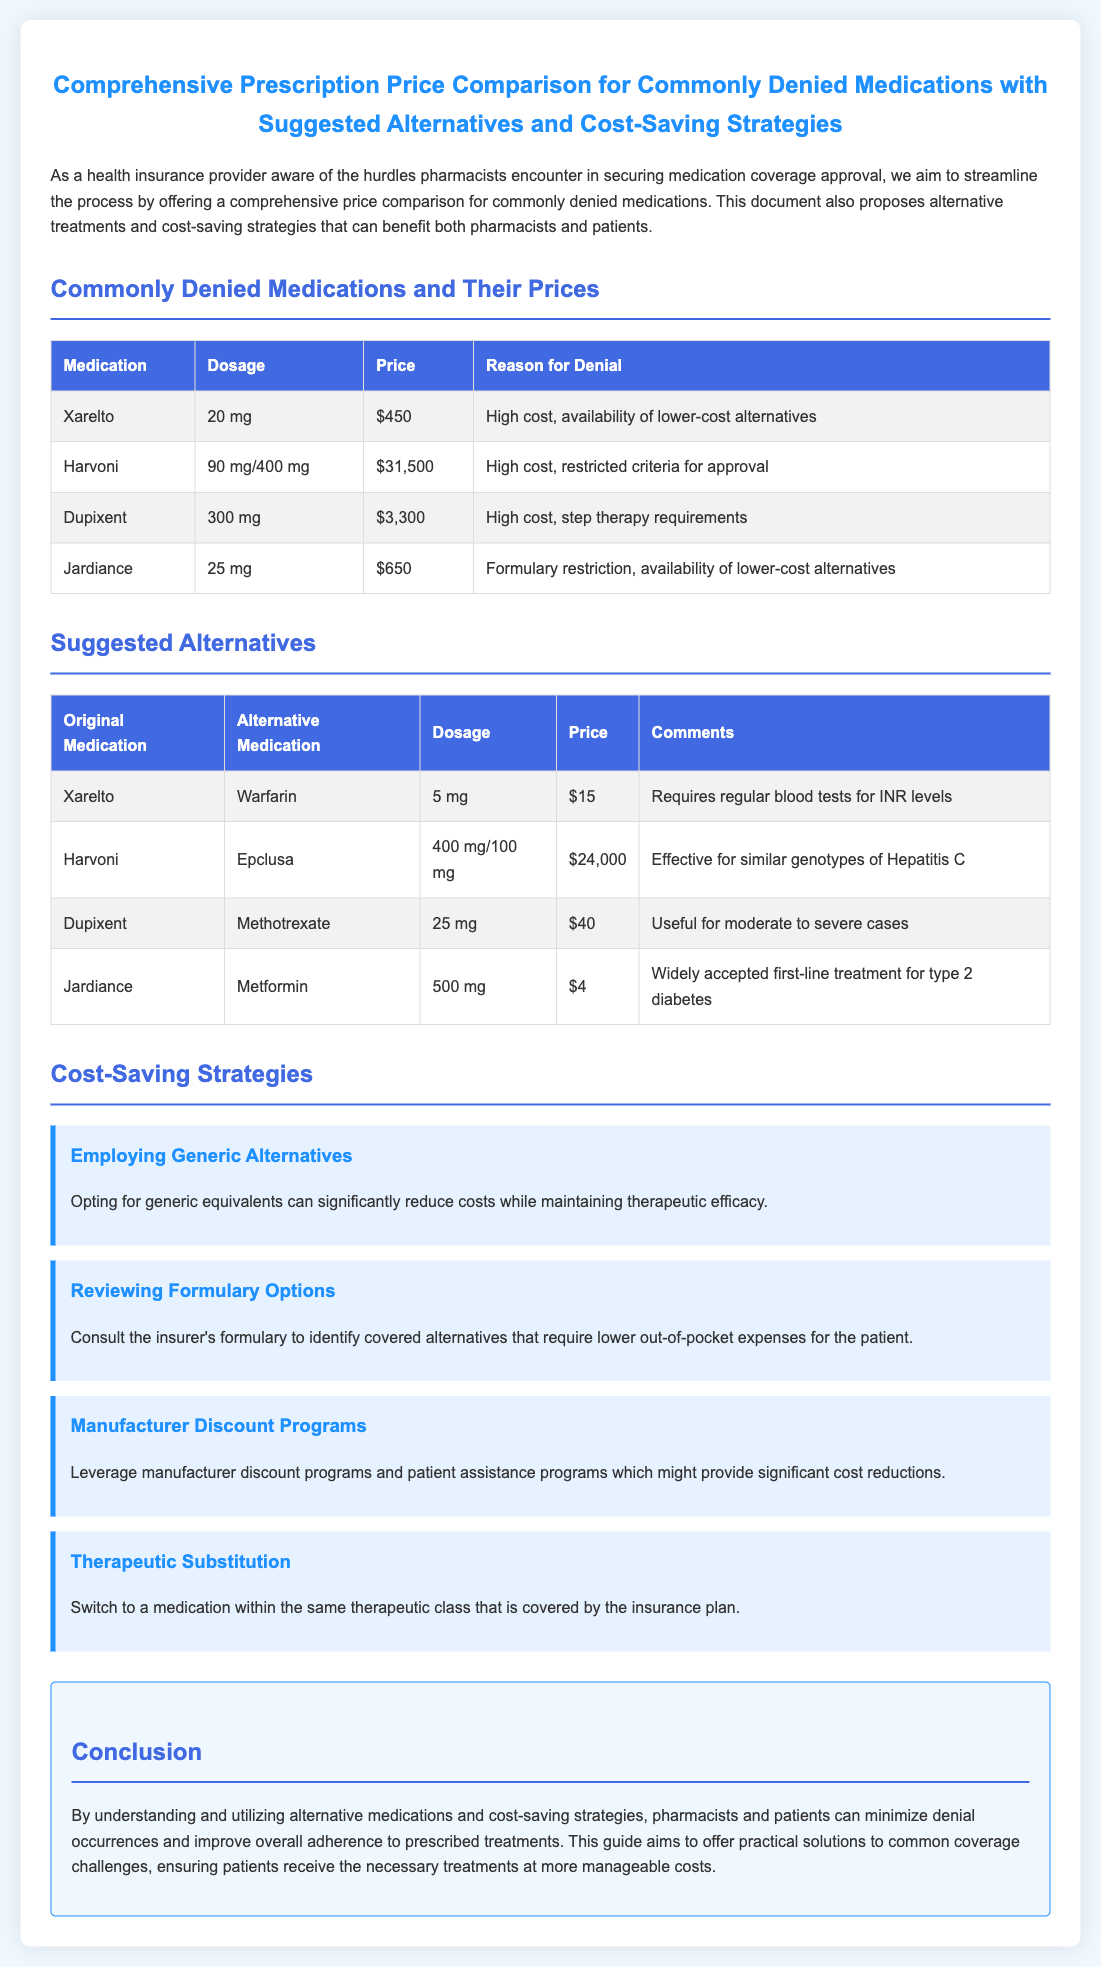What is the price of Xarelto? The price of Xarelto is listed in the document in the medication table.
Answer: $450 What is the alternative medication for Harvoni? The document provides a table with original medications and their suggested alternatives.
Answer: Epclusa What dosage of Metformin is suggested as an alternative to Jardiance? The dosage is included in the alternatives table for Jardiance.
Answer: 500 mg What is the reason for denial of Dupixent? The document specifies reasons for denial for each medication in the table.
Answer: High cost, step therapy requirements What cost-saving strategy suggests using generic medications? The strategies listed in the document provide ways to save costs.
Answer: Employing Generic Alternatives What is the price of the alternative medication to Xarelto? The price of the alternative medication is contained within the alternatives table.
Answer: $15 How much does Harvoni cost? The price is mentioned in the table of commonly denied medications.
Answer: $31,500 What is the suggested alternative for Dupixent? This is detailed in the alternatives table.
Answer: Methotrexate What does the document advise to consult for lower out-of-pocket expenses? The strategies section contains suggestions for reducing costs for patients.
Answer: Formulary Options 